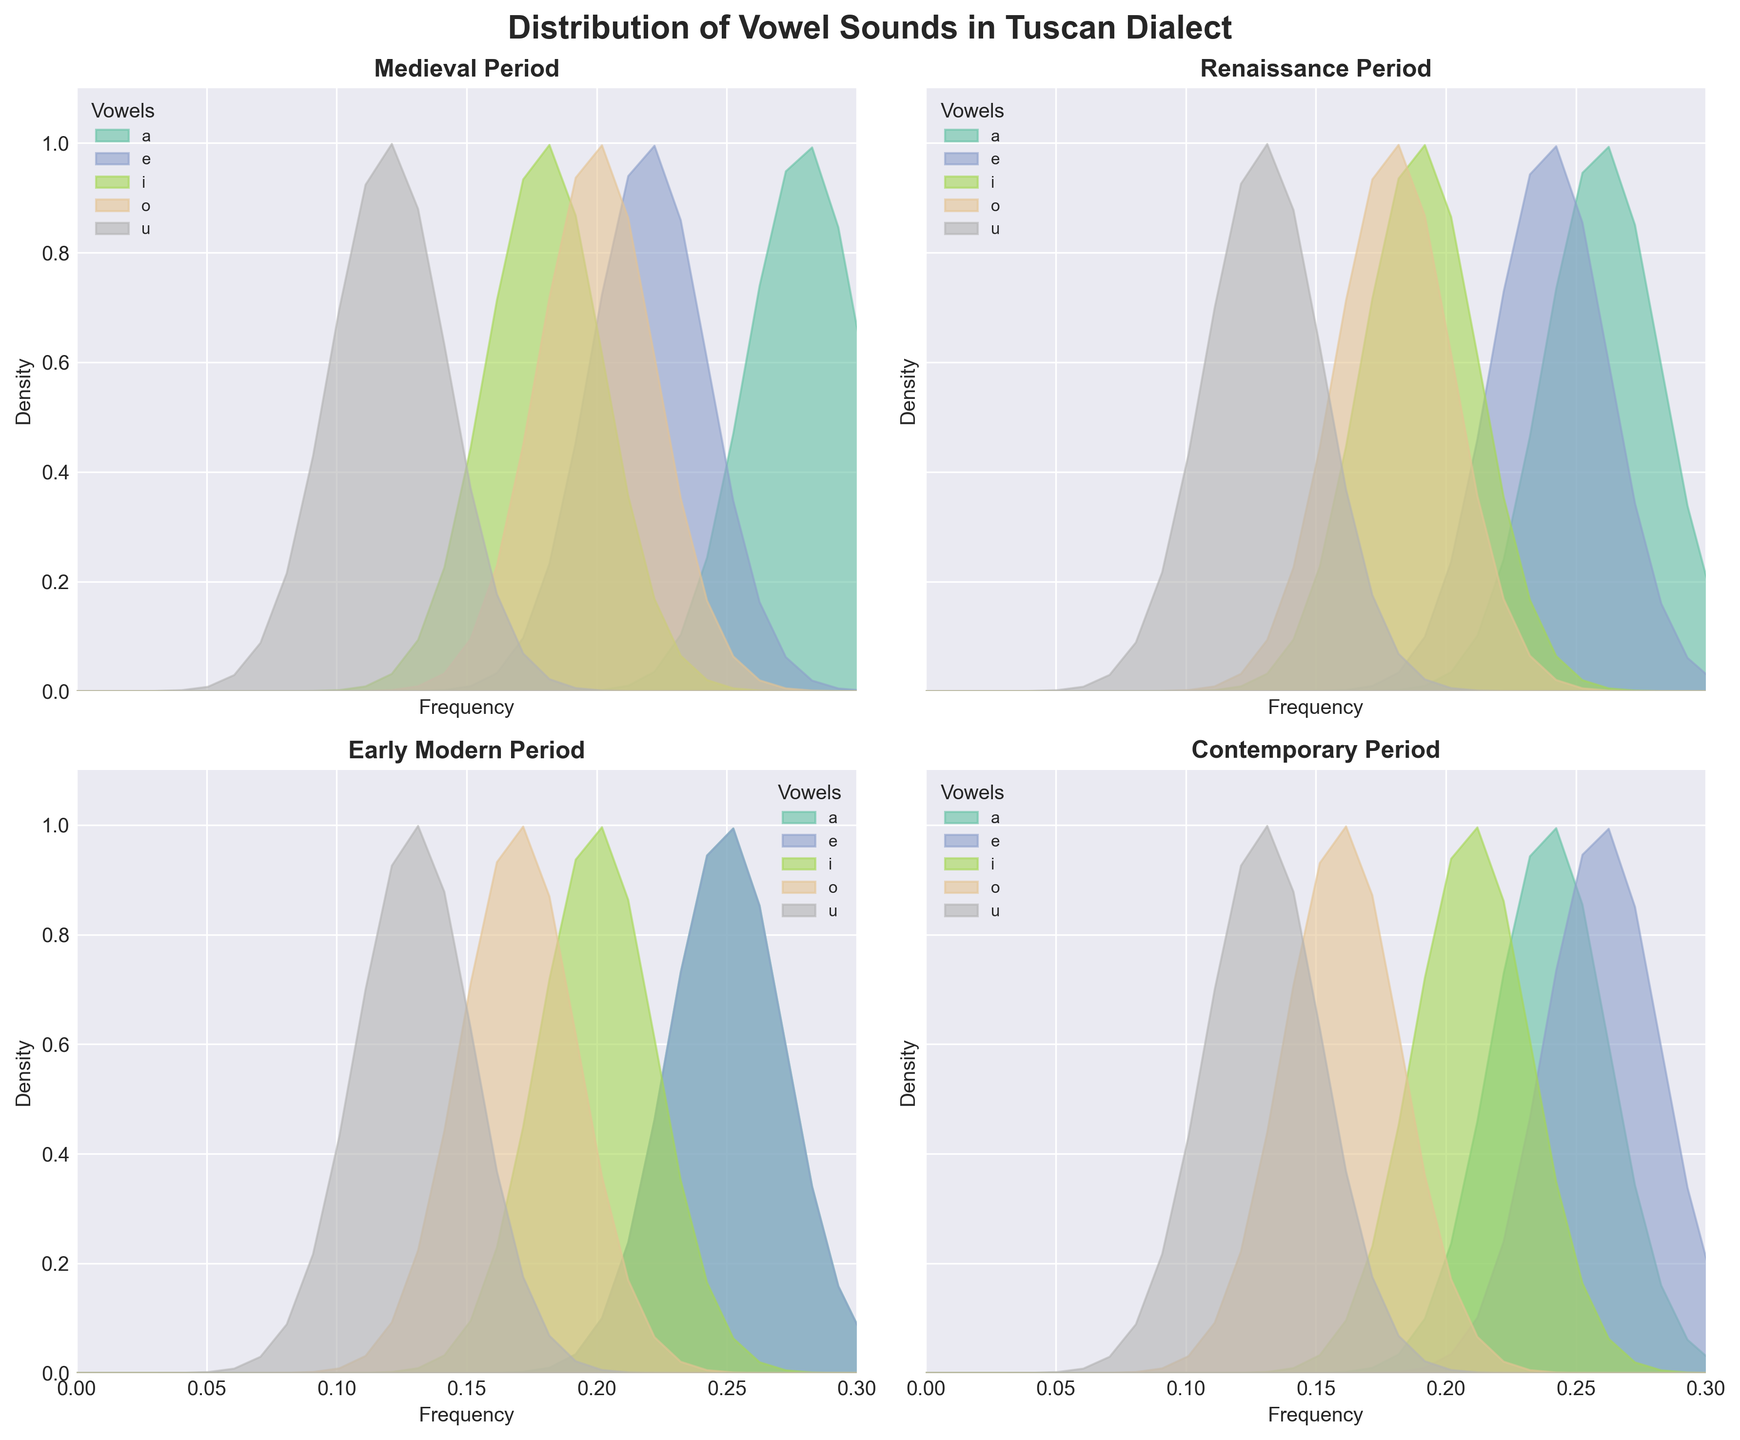What is the title of the figure? The title is usually displayed at the top of the figure, summarizing the main content. In this case, it reads "Distribution of Vowel Sounds in Tuscan Dialect."
Answer: Distribution of Vowel Sounds in Tuscan Dialect How many historical periods are represented in the figure? To determine this, we look at the subplots, each representing a different historical period: Medieval, Renaissance, Early Modern, and Contemporary. This makes a total of four periods.
Answer: Four Which vowel has the highest frequency in the Contemporary period? By examining the subplot labeled "Contemporary Period," we see that the vowel 'e' has the highest frequency, as it appears at a leftmost position compared to other vowels.
Answer: e How do the frequencies of the vowel 'a' change from the Medieval to the Contemporary period? To compute this, we locate the frequency of 'a' in each period. Medieval: 0.28, Renaissance: 0.26, Early Modern: 0.25, Contemporary: 0.24. It shows a gradual decrease from 0.28 to 0.24 across these periods.
Answer: It decreases Which period shows the most balanced distribution of vowel sounds? The balance can be judged by how evenly spread the frequencies are for each vowel in a given period. The Early Modern period shows frequencies: a=0.25, e=0.25, i=0.20, o=0.17, u=0.13, which appear most balanced.
Answer: Early Modern What is the frequency difference of the vowel 'i' between the Renaissance and Early Modern periods? By finding the frequency of 'i' in both periods: Renaissance (0.19) and Early Modern (0.20), and calculating their difference yields 0.01.
Answer: 0.01 Which vowel remains constant in frequency from the Renaissance to the Contemporary period? By observing each vowel's frequency, we see the vowel 'u' holds a constant frequency of 0.13 in both Renaissance and Contemporary periods.
Answer: u How does the density curve of the vowel 'o' appear in the Medieval period? In the Medieval subplot, the frequency of 'o' is 0.20. The density curve follows a pattern with peak density at this frequency and symmetrically decreases on both sides, forming a bell curve.
Answer: Bell-shaped around 0.20 